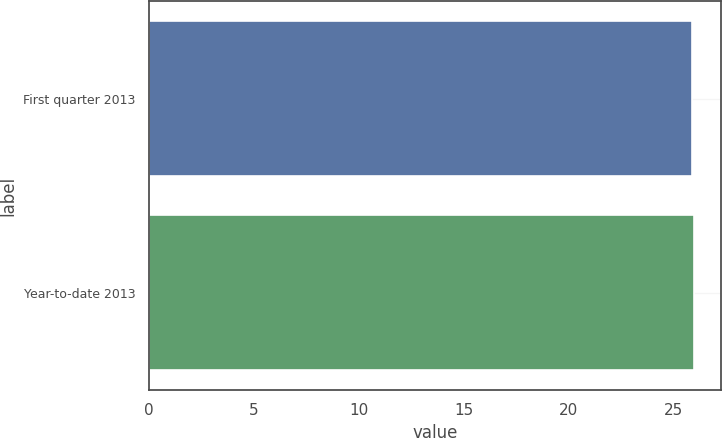Convert chart. <chart><loc_0><loc_0><loc_500><loc_500><bar_chart><fcel>First quarter 2013<fcel>Year-to-date 2013<nl><fcel>25.88<fcel>25.98<nl></chart> 